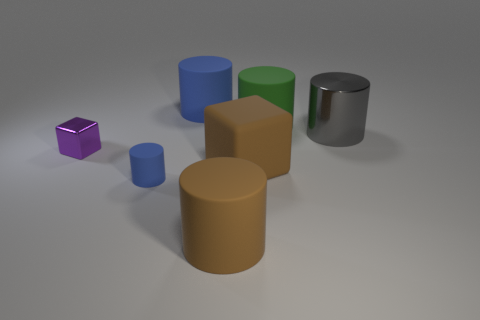What color is the shiny cylinder that is the same size as the brown rubber cylinder?
Ensure brevity in your answer.  Gray. What number of other things are there of the same shape as the small rubber object?
Your response must be concise. 4. Is the brown cylinder the same size as the green rubber thing?
Your answer should be very brief. Yes. Is the number of cylinders that are in front of the green matte cylinder greater than the number of brown cubes behind the small matte thing?
Your answer should be very brief. Yes. How many other things are the same size as the purple thing?
Your answer should be compact. 1. There is a big matte thing in front of the brown cube; does it have the same color as the large rubber block?
Keep it short and to the point. Yes. Is the number of big matte blocks that are to the left of the large green matte cylinder greater than the number of large cyan cubes?
Give a very brief answer. Yes. Is there anything else of the same color as the big metallic cylinder?
Keep it short and to the point. No. There is a tiny blue thing left of the brown object that is on the right side of the brown matte cylinder; what shape is it?
Provide a succinct answer. Cylinder. Is the number of big gray metallic cylinders greater than the number of rubber cylinders?
Provide a succinct answer. No. 